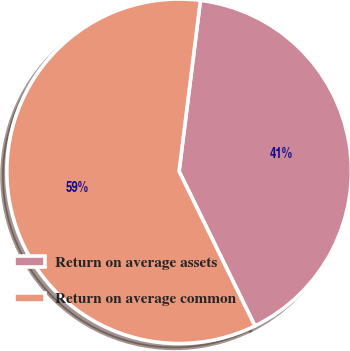Convert chart to OTSL. <chart><loc_0><loc_0><loc_500><loc_500><pie_chart><fcel>Return on average assets<fcel>Return on average common<nl><fcel>40.77%<fcel>59.23%<nl></chart> 